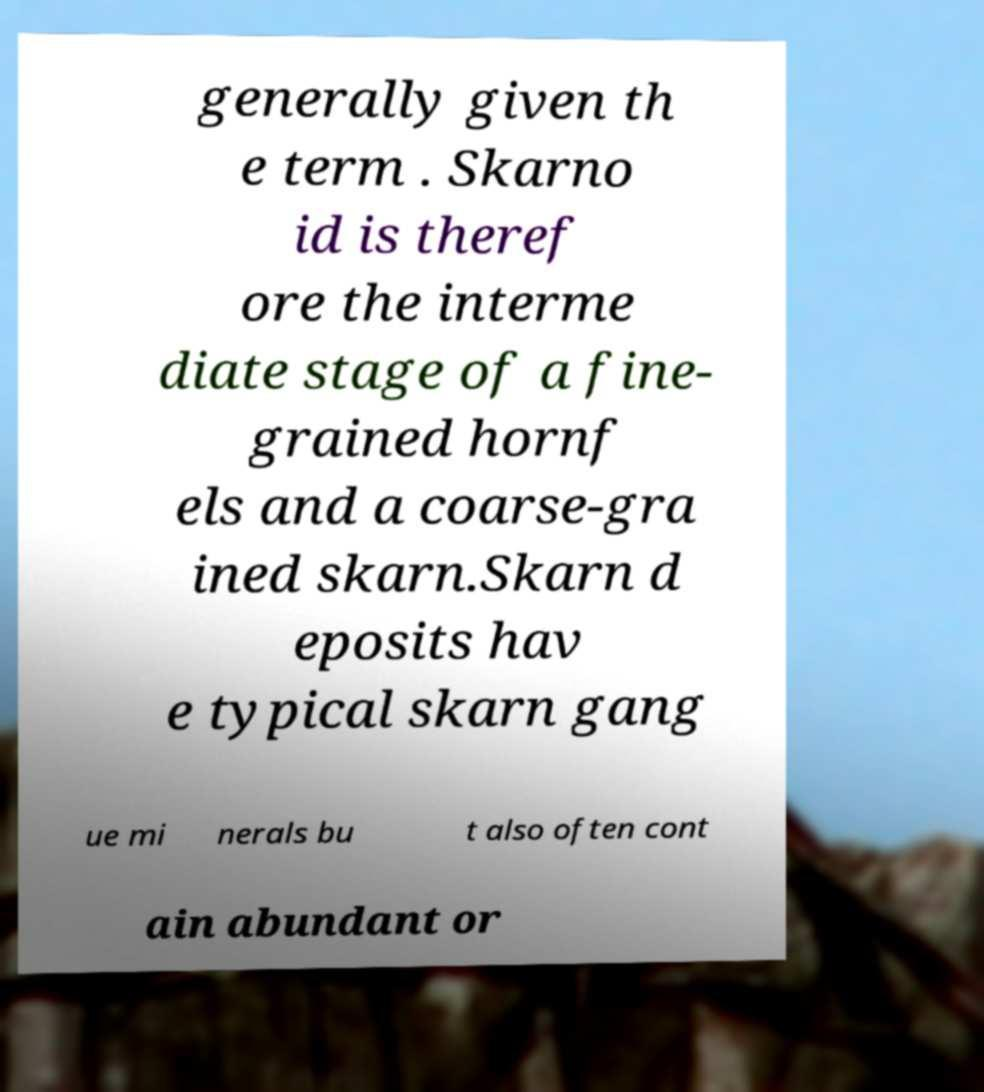What messages or text are displayed in this image? I need them in a readable, typed format. generally given th e term . Skarno id is theref ore the interme diate stage of a fine- grained hornf els and a coarse-gra ined skarn.Skarn d eposits hav e typical skarn gang ue mi nerals bu t also often cont ain abundant or 